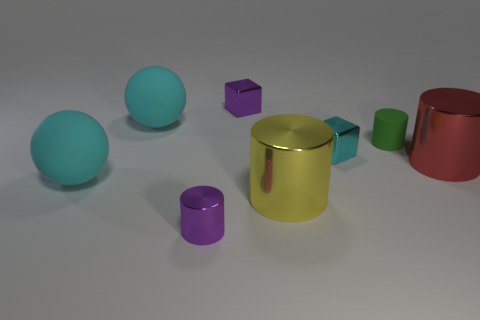Subtract all matte cylinders. How many cylinders are left? 3 Subtract all red cylinders. How many cylinders are left? 3 Subtract all blocks. How many objects are left? 6 Add 1 cyan matte objects. How many objects exist? 9 Add 5 red shiny objects. How many red shiny objects exist? 6 Subtract 1 yellow cylinders. How many objects are left? 7 Subtract all purple blocks. Subtract all gray cylinders. How many blocks are left? 1 Subtract all large matte things. Subtract all tiny shiny cylinders. How many objects are left? 5 Add 3 large cyan things. How many large cyan things are left? 5 